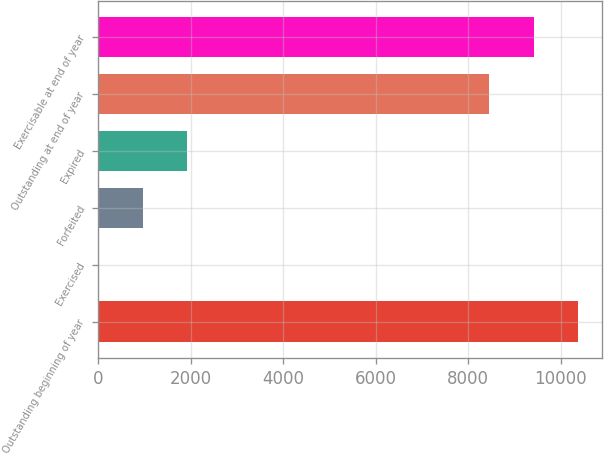Convert chart to OTSL. <chart><loc_0><loc_0><loc_500><loc_500><bar_chart><fcel>Outstanding beginning of year<fcel>Exercised<fcel>Forfeited<fcel>Expired<fcel>Outstanding at end of year<fcel>Exercisable at end of year<nl><fcel>10367<fcel>12<fcel>965.5<fcel>1919<fcel>8460<fcel>9413.5<nl></chart> 